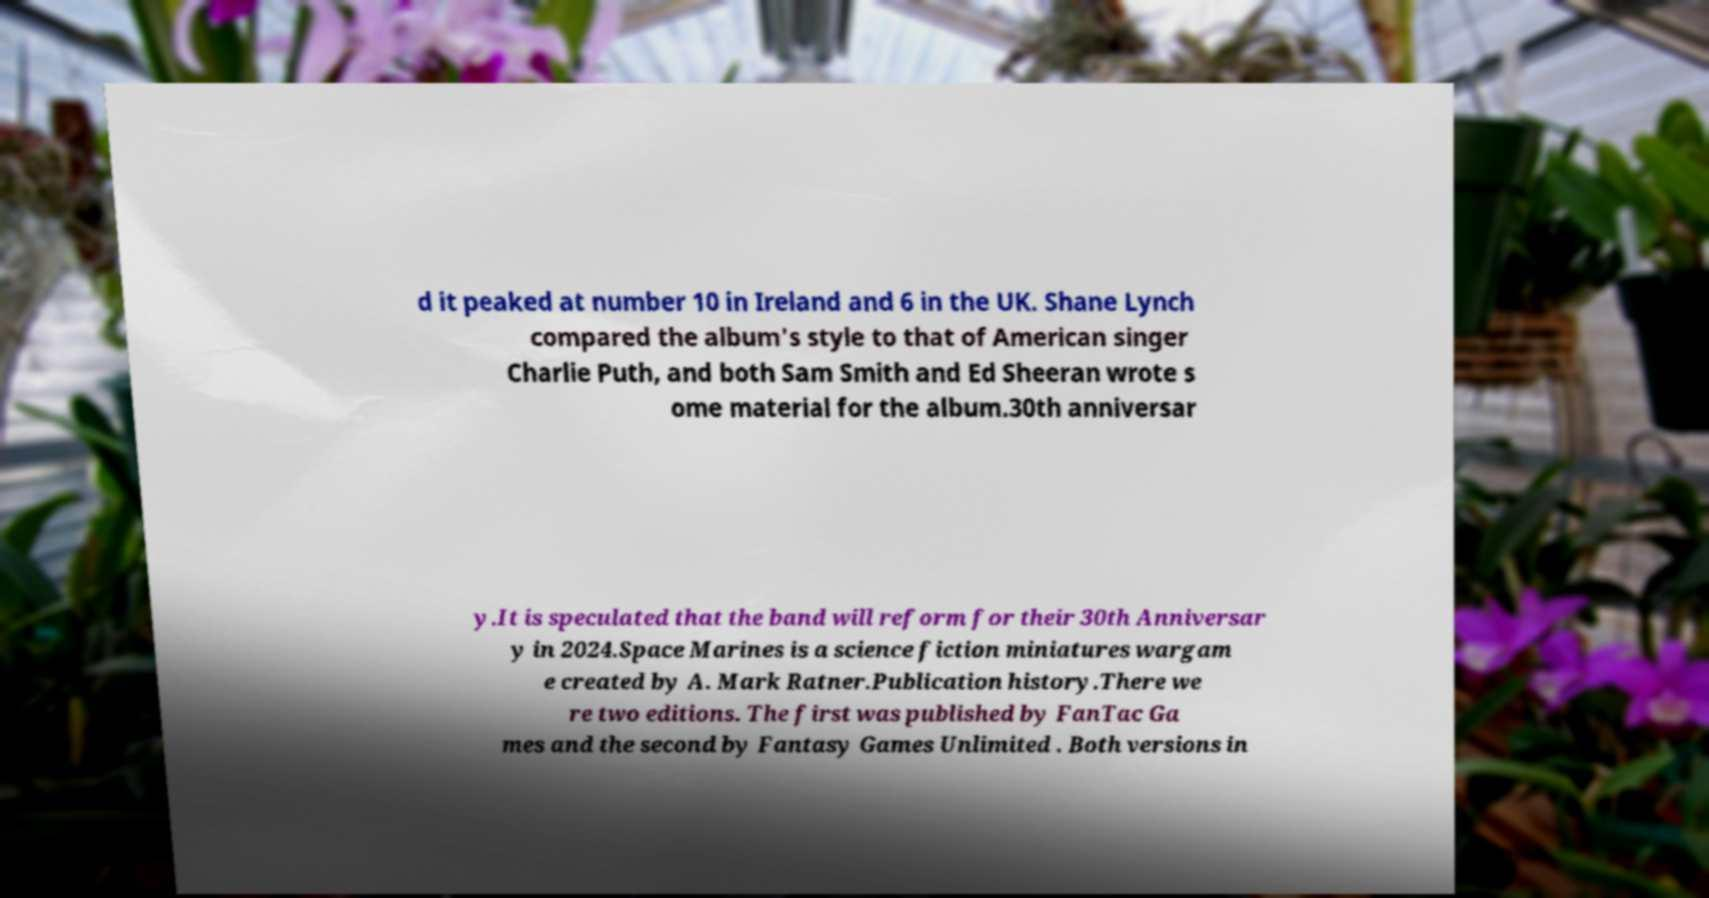I need the written content from this picture converted into text. Can you do that? d it peaked at number 10 in Ireland and 6 in the UK. Shane Lynch compared the album's style to that of American singer Charlie Puth, and both Sam Smith and Ed Sheeran wrote s ome material for the album.30th anniversar y.It is speculated that the band will reform for their 30th Anniversar y in 2024.Space Marines is a science fiction miniatures wargam e created by A. Mark Ratner.Publication history.There we re two editions. The first was published by FanTac Ga mes and the second by Fantasy Games Unlimited . Both versions in 